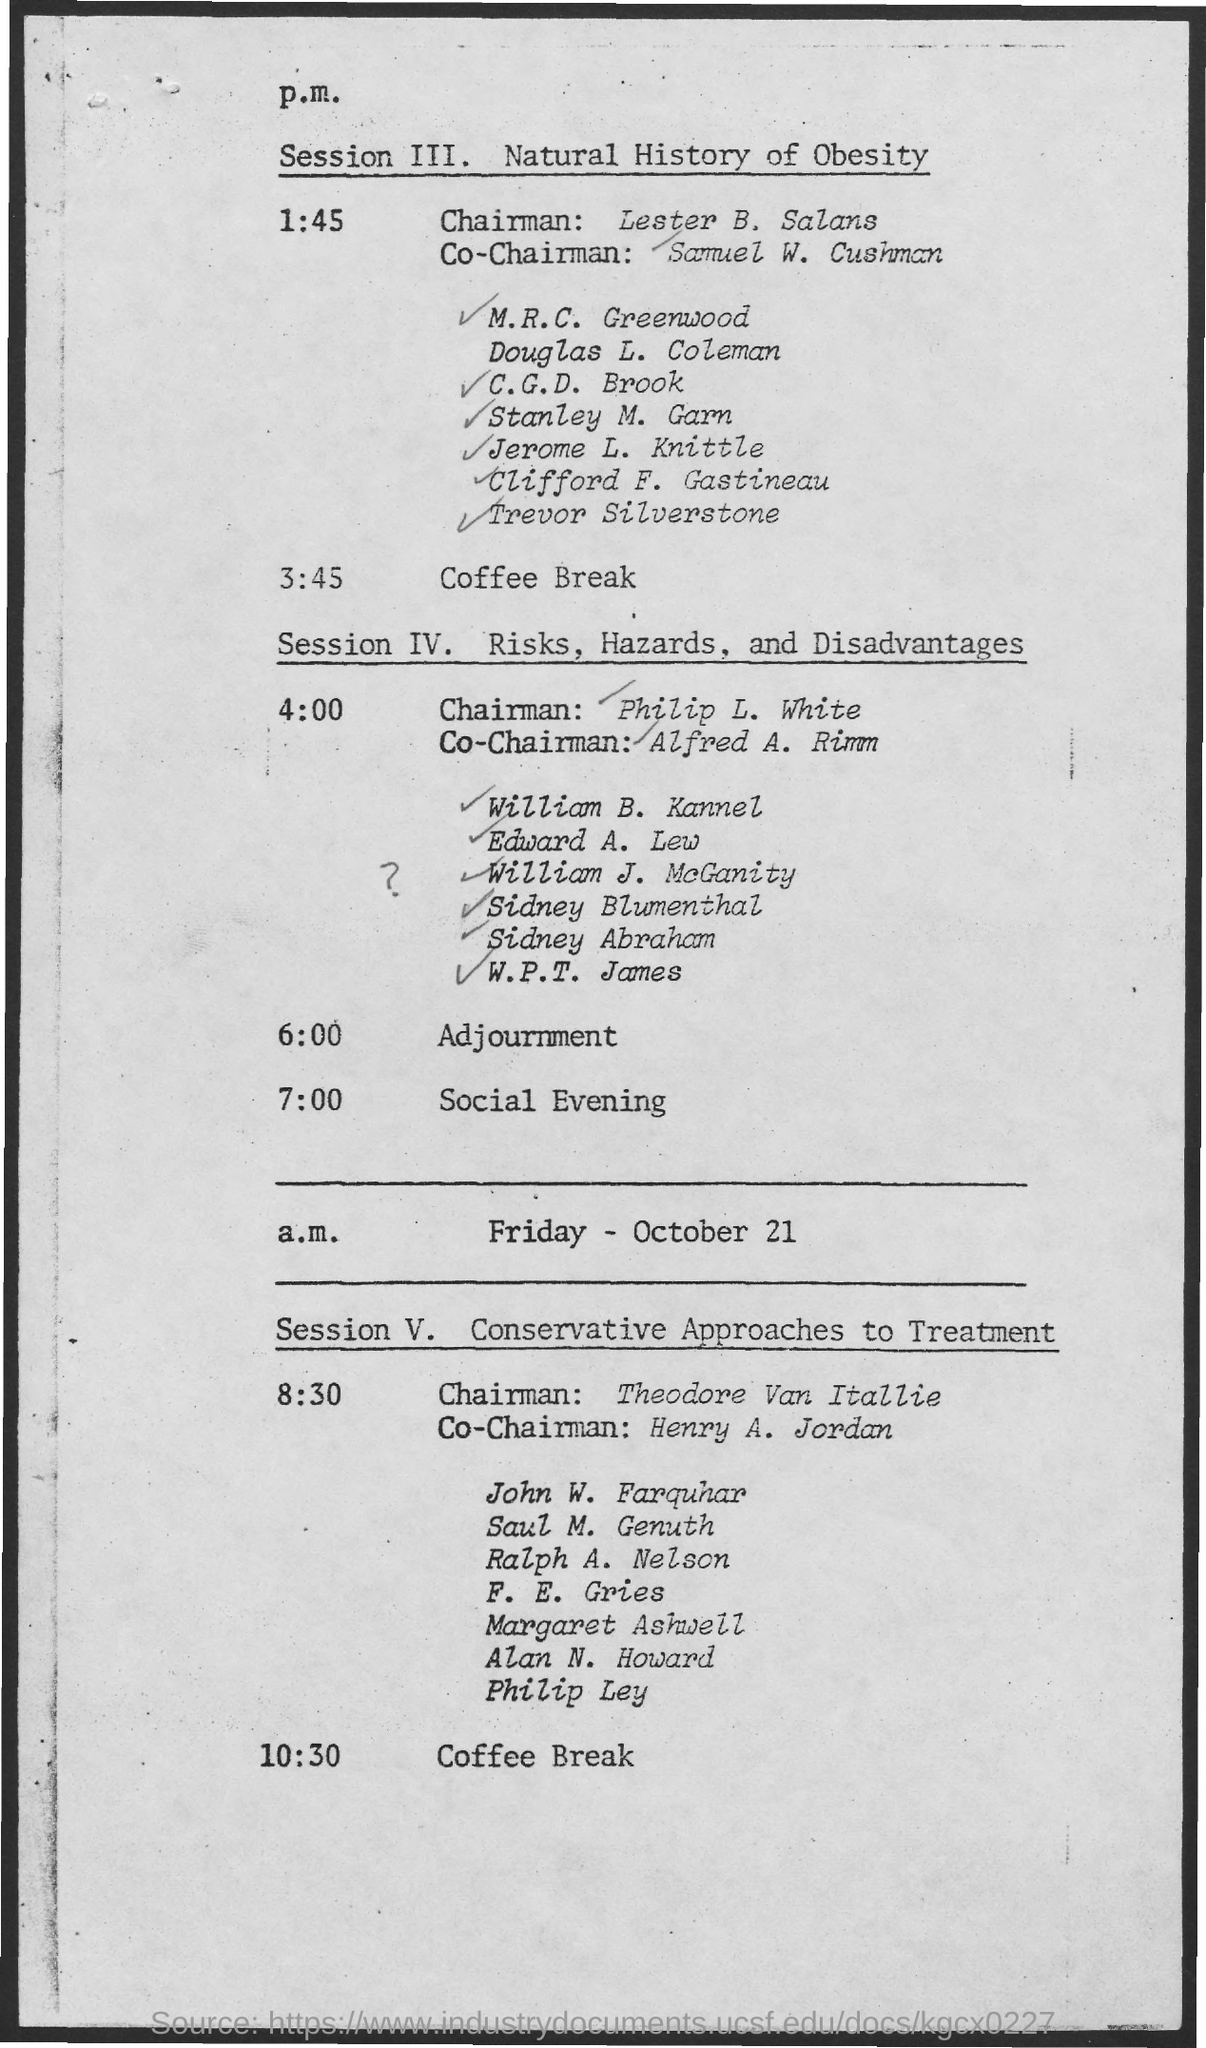Point out several critical features in this image. The Co-Chairman for Session ɪɪɪ. is Samuel W. Cushman. The Co-Chairman for Session V. is Henry A. Jordan. In Session V, the discussion focuses on conservative approaches to treatment. The chairman for Session ɪɪɪ. is Lester B. Salans. Session IV discusses the risks, hazards, and disadvantages of the construction of the third airport in the capital region. 